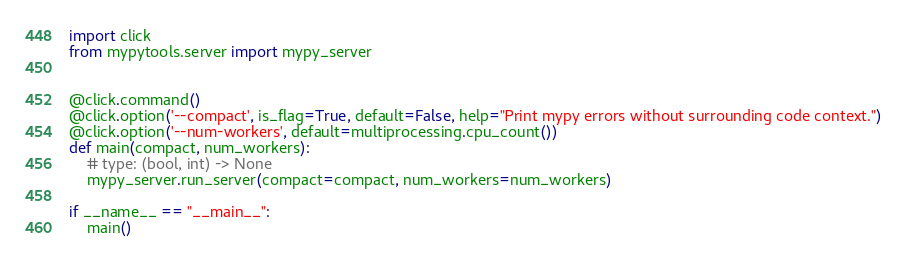<code> <loc_0><loc_0><loc_500><loc_500><_Python_>import click
from mypytools.server import mypy_server


@click.command()
@click.option('--compact', is_flag=True, default=False, help="Print mypy errors without surrounding code context.")
@click.option('--num-workers', default=multiprocessing.cpu_count())
def main(compact, num_workers):
    # type: (bool, int) -> None
    mypy_server.run_server(compact=compact, num_workers=num_workers)

if __name__ == "__main__":
    main()
</code> 